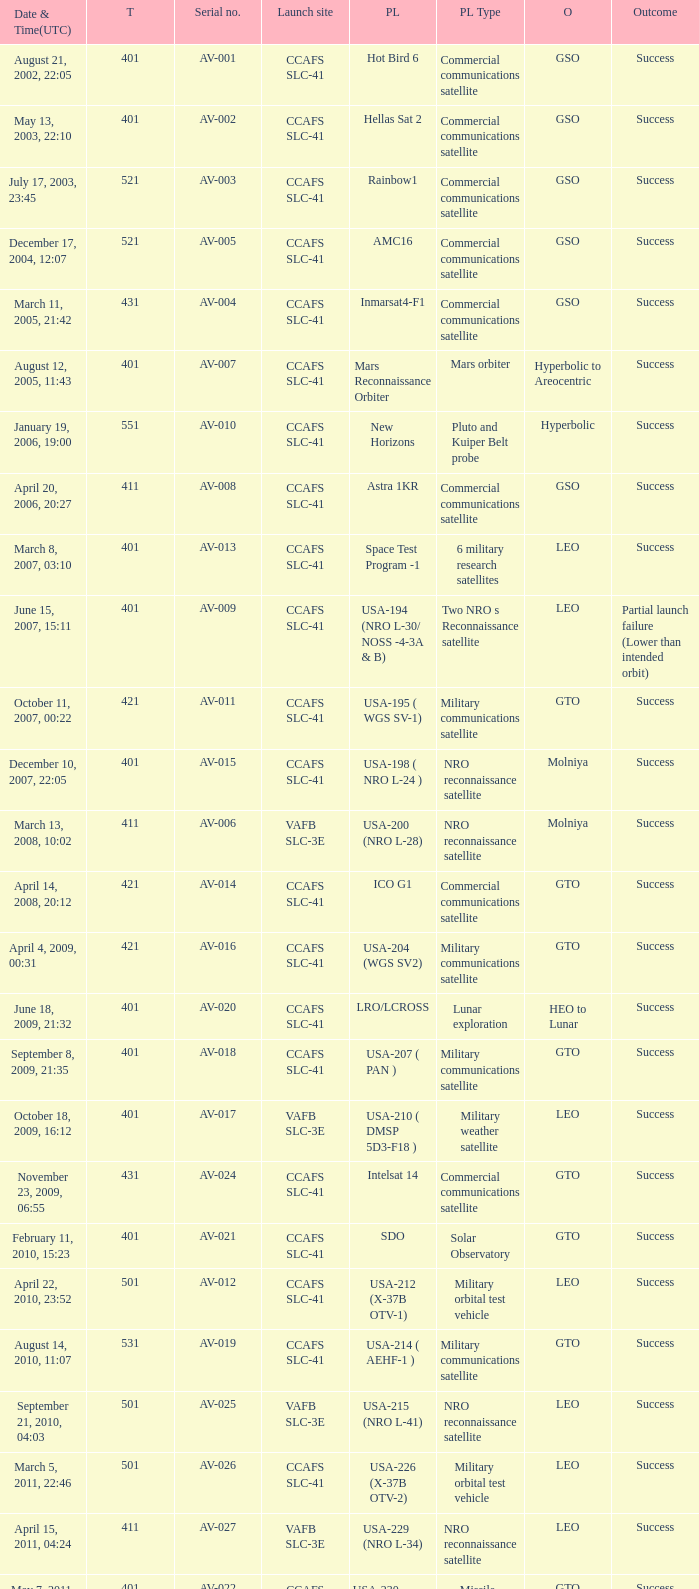When was the payload of Commercial Communications Satellite amc16? December 17, 2004, 12:07. 